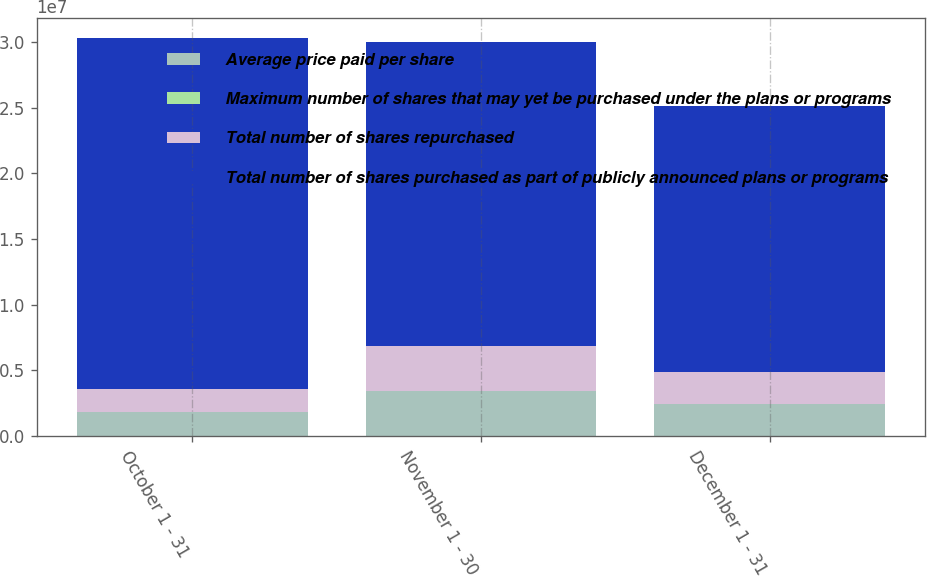Convert chart to OTSL. <chart><loc_0><loc_0><loc_500><loc_500><stacked_bar_chart><ecel><fcel>October 1 - 31<fcel>November 1 - 30<fcel>December 1 - 31<nl><fcel>Average price paid per share<fcel>1.7874e+06<fcel>3.43978e+06<fcel>2.45481e+06<nl><fcel>Maximum number of shares that may yet be purchased under the plans or programs<fcel>12.65<fcel>12.81<fcel>12.94<nl><fcel>Total number of shares repurchased<fcel>1.7778e+06<fcel>3.43425e+06<fcel>2.44727e+06<nl><fcel>Total number of shares purchased as part of publicly announced plans or programs<fcel>2.67506e+07<fcel>2.30824e+07<fcel>2.02465e+07<nl></chart> 